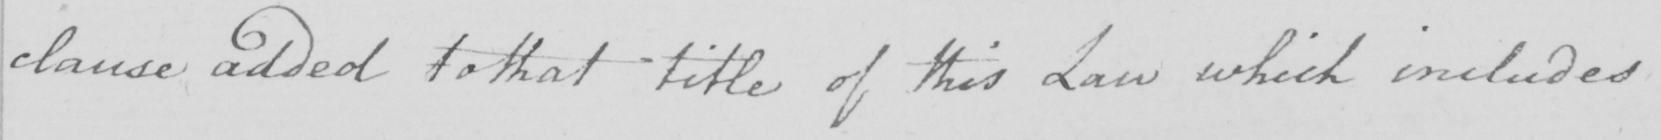What text is written in this handwritten line? clause added to that title of this Law which includes 